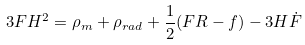<formula> <loc_0><loc_0><loc_500><loc_500>3 F H ^ { 2 } = \rho _ { m } + \rho _ { r a d } + { \frac { 1 } { 2 } } ( F R - f ) - 3 H { \dot { F } }</formula> 